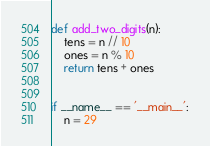Convert code to text. <code><loc_0><loc_0><loc_500><loc_500><_Python_>def add_two_digits(n):
    tens = n // 10
    ones = n % 10
    return tens + ones


if __name__ == '__main__':
    n = 29</code> 